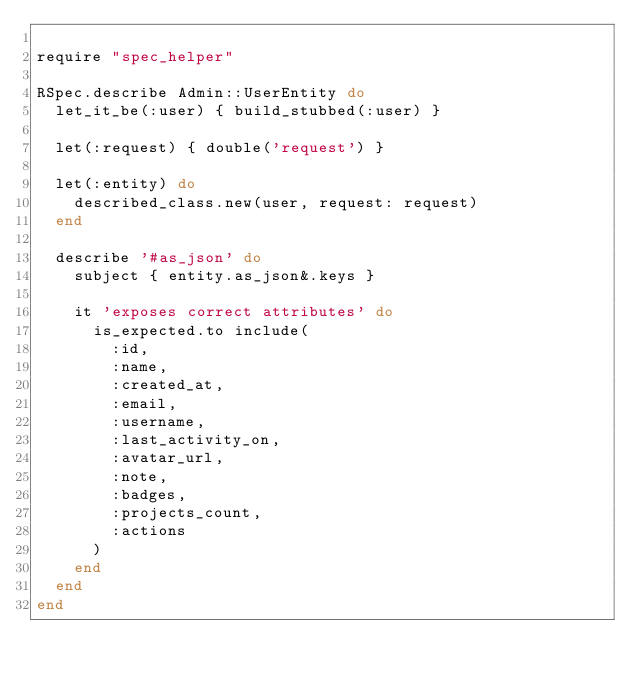<code> <loc_0><loc_0><loc_500><loc_500><_Ruby_>
require "spec_helper"

RSpec.describe Admin::UserEntity do
  let_it_be(:user) { build_stubbed(:user) }

  let(:request) { double('request') }

  let(:entity) do
    described_class.new(user, request: request)
  end

  describe '#as_json' do
    subject { entity.as_json&.keys }

    it 'exposes correct attributes' do
      is_expected.to include(
        :id,
        :name,
        :created_at,
        :email,
        :username,
        :last_activity_on,
        :avatar_url,
        :note,
        :badges,
        :projects_count,
        :actions
      )
    end
  end
end
</code> 